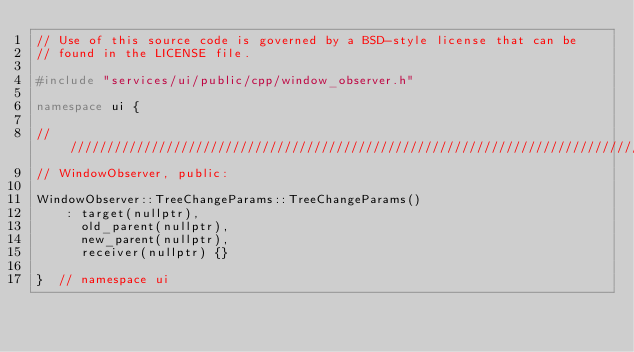<code> <loc_0><loc_0><loc_500><loc_500><_C++_>// Use of this source code is governed by a BSD-style license that can be
// found in the LICENSE file.

#include "services/ui/public/cpp/window_observer.h"

namespace ui {

////////////////////////////////////////////////////////////////////////////////
// WindowObserver, public:

WindowObserver::TreeChangeParams::TreeChangeParams()
    : target(nullptr),
      old_parent(nullptr),
      new_parent(nullptr),
      receiver(nullptr) {}

}  // namespace ui
</code> 